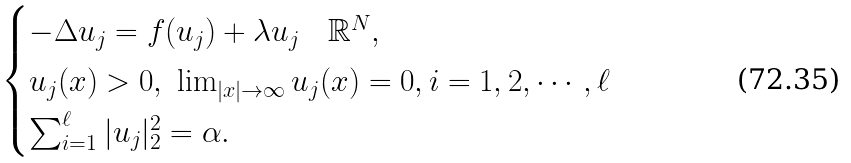<formula> <loc_0><loc_0><loc_500><loc_500>\begin{cases} - \Delta u _ { j } = f ( u _ { j } ) + \lambda u _ { j } \quad \mathbb { R } ^ { N } , \\ u _ { j } ( x ) > 0 , \ \lim _ { | x | \to \infty } u _ { j } ( x ) = 0 , i = 1 , 2 , \cdots , \ell \\ \sum _ { i = 1 } ^ { \ell } | u _ { j } | _ { 2 } ^ { 2 } = \alpha . \end{cases}</formula> 